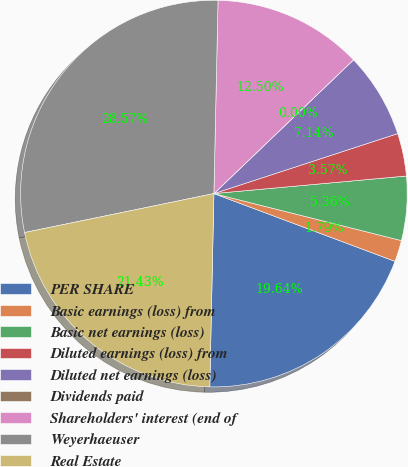Convert chart to OTSL. <chart><loc_0><loc_0><loc_500><loc_500><pie_chart><fcel>PER SHARE<fcel>Basic earnings (loss) from<fcel>Basic net earnings (loss)<fcel>Diluted earnings (loss) from<fcel>Diluted net earnings (loss)<fcel>Dividends paid<fcel>Shareholders' interest (end of<fcel>Weyerhaeuser<fcel>Real Estate<nl><fcel>19.64%<fcel>1.79%<fcel>5.36%<fcel>3.57%<fcel>7.14%<fcel>0.0%<fcel>12.5%<fcel>28.57%<fcel>21.43%<nl></chart> 